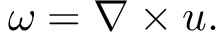Convert formula to latex. <formula><loc_0><loc_0><loc_500><loc_500>{ \omega } = \nabla \times { u } .</formula> 